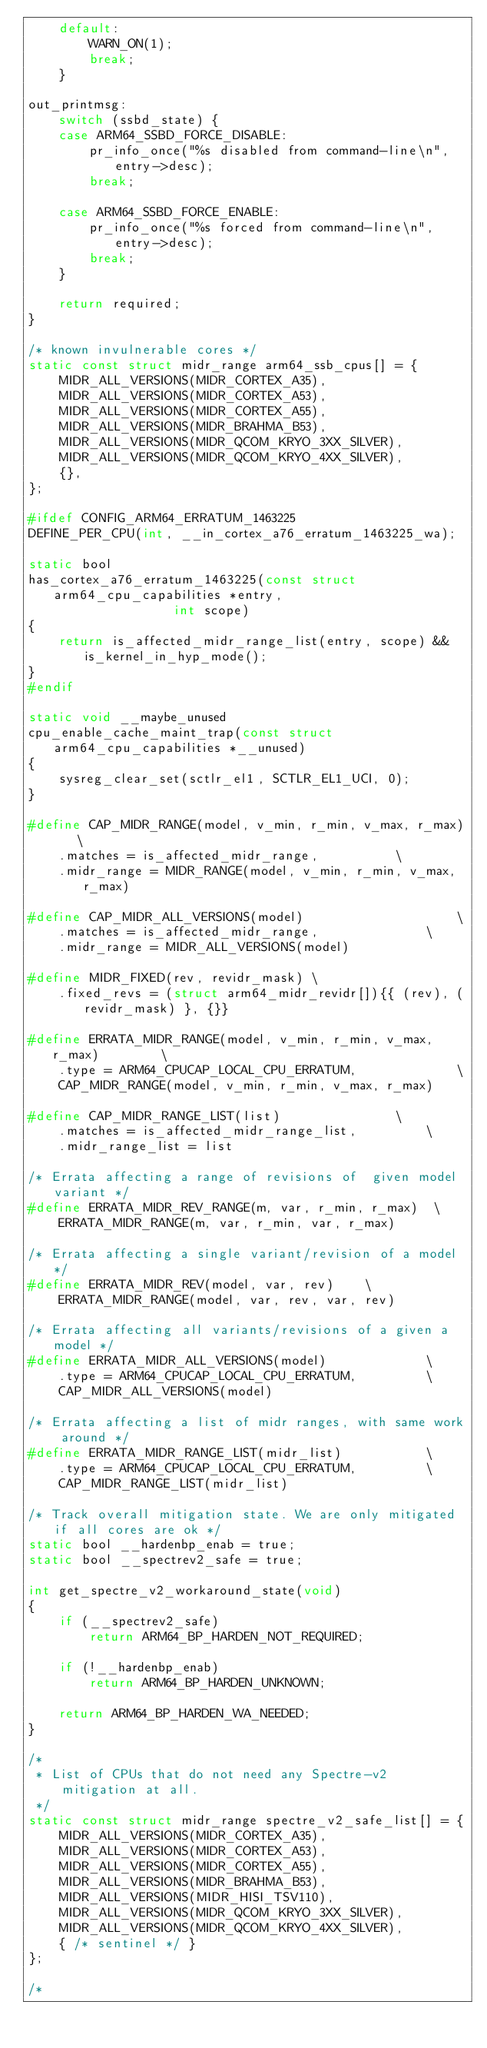<code> <loc_0><loc_0><loc_500><loc_500><_C_>	default:
		WARN_ON(1);
		break;
	}

out_printmsg:
	switch (ssbd_state) {
	case ARM64_SSBD_FORCE_DISABLE:
		pr_info_once("%s disabled from command-line\n", entry->desc);
		break;

	case ARM64_SSBD_FORCE_ENABLE:
		pr_info_once("%s forced from command-line\n", entry->desc);
		break;
	}

	return required;
}

/* known invulnerable cores */
static const struct midr_range arm64_ssb_cpus[] = {
	MIDR_ALL_VERSIONS(MIDR_CORTEX_A35),
	MIDR_ALL_VERSIONS(MIDR_CORTEX_A53),
	MIDR_ALL_VERSIONS(MIDR_CORTEX_A55),
	MIDR_ALL_VERSIONS(MIDR_BRAHMA_B53),
	MIDR_ALL_VERSIONS(MIDR_QCOM_KRYO_3XX_SILVER),
	MIDR_ALL_VERSIONS(MIDR_QCOM_KRYO_4XX_SILVER),
	{},
};

#ifdef CONFIG_ARM64_ERRATUM_1463225
DEFINE_PER_CPU(int, __in_cortex_a76_erratum_1463225_wa);

static bool
has_cortex_a76_erratum_1463225(const struct arm64_cpu_capabilities *entry,
			       int scope)
{
	return is_affected_midr_range_list(entry, scope) && is_kernel_in_hyp_mode();
}
#endif

static void __maybe_unused
cpu_enable_cache_maint_trap(const struct arm64_cpu_capabilities *__unused)
{
	sysreg_clear_set(sctlr_el1, SCTLR_EL1_UCI, 0);
}

#define CAP_MIDR_RANGE(model, v_min, r_min, v_max, r_max)	\
	.matches = is_affected_midr_range,			\
	.midr_range = MIDR_RANGE(model, v_min, r_min, v_max, r_max)

#define CAP_MIDR_ALL_VERSIONS(model)					\
	.matches = is_affected_midr_range,				\
	.midr_range = MIDR_ALL_VERSIONS(model)

#define MIDR_FIXED(rev, revidr_mask) \
	.fixed_revs = (struct arm64_midr_revidr[]){{ (rev), (revidr_mask) }, {}}

#define ERRATA_MIDR_RANGE(model, v_min, r_min, v_max, r_max)		\
	.type = ARM64_CPUCAP_LOCAL_CPU_ERRATUM,				\
	CAP_MIDR_RANGE(model, v_min, r_min, v_max, r_max)

#define CAP_MIDR_RANGE_LIST(list)				\
	.matches = is_affected_midr_range_list,			\
	.midr_range_list = list

/* Errata affecting a range of revisions of  given model variant */
#define ERRATA_MIDR_REV_RANGE(m, var, r_min, r_max)	 \
	ERRATA_MIDR_RANGE(m, var, r_min, var, r_max)

/* Errata affecting a single variant/revision of a model */
#define ERRATA_MIDR_REV(model, var, rev)	\
	ERRATA_MIDR_RANGE(model, var, rev, var, rev)

/* Errata affecting all variants/revisions of a given a model */
#define ERRATA_MIDR_ALL_VERSIONS(model)				\
	.type = ARM64_CPUCAP_LOCAL_CPU_ERRATUM,			\
	CAP_MIDR_ALL_VERSIONS(model)

/* Errata affecting a list of midr ranges, with same work around */
#define ERRATA_MIDR_RANGE_LIST(midr_list)			\
	.type = ARM64_CPUCAP_LOCAL_CPU_ERRATUM,			\
	CAP_MIDR_RANGE_LIST(midr_list)

/* Track overall mitigation state. We are only mitigated if all cores are ok */
static bool __hardenbp_enab = true;
static bool __spectrev2_safe = true;

int get_spectre_v2_workaround_state(void)
{
	if (__spectrev2_safe)
		return ARM64_BP_HARDEN_NOT_REQUIRED;

	if (!__hardenbp_enab)
		return ARM64_BP_HARDEN_UNKNOWN;

	return ARM64_BP_HARDEN_WA_NEEDED;
}

/*
 * List of CPUs that do not need any Spectre-v2 mitigation at all.
 */
static const struct midr_range spectre_v2_safe_list[] = {
	MIDR_ALL_VERSIONS(MIDR_CORTEX_A35),
	MIDR_ALL_VERSIONS(MIDR_CORTEX_A53),
	MIDR_ALL_VERSIONS(MIDR_CORTEX_A55),
	MIDR_ALL_VERSIONS(MIDR_BRAHMA_B53),
	MIDR_ALL_VERSIONS(MIDR_HISI_TSV110),
	MIDR_ALL_VERSIONS(MIDR_QCOM_KRYO_3XX_SILVER),
	MIDR_ALL_VERSIONS(MIDR_QCOM_KRYO_4XX_SILVER),
	{ /* sentinel */ }
};

/*</code> 